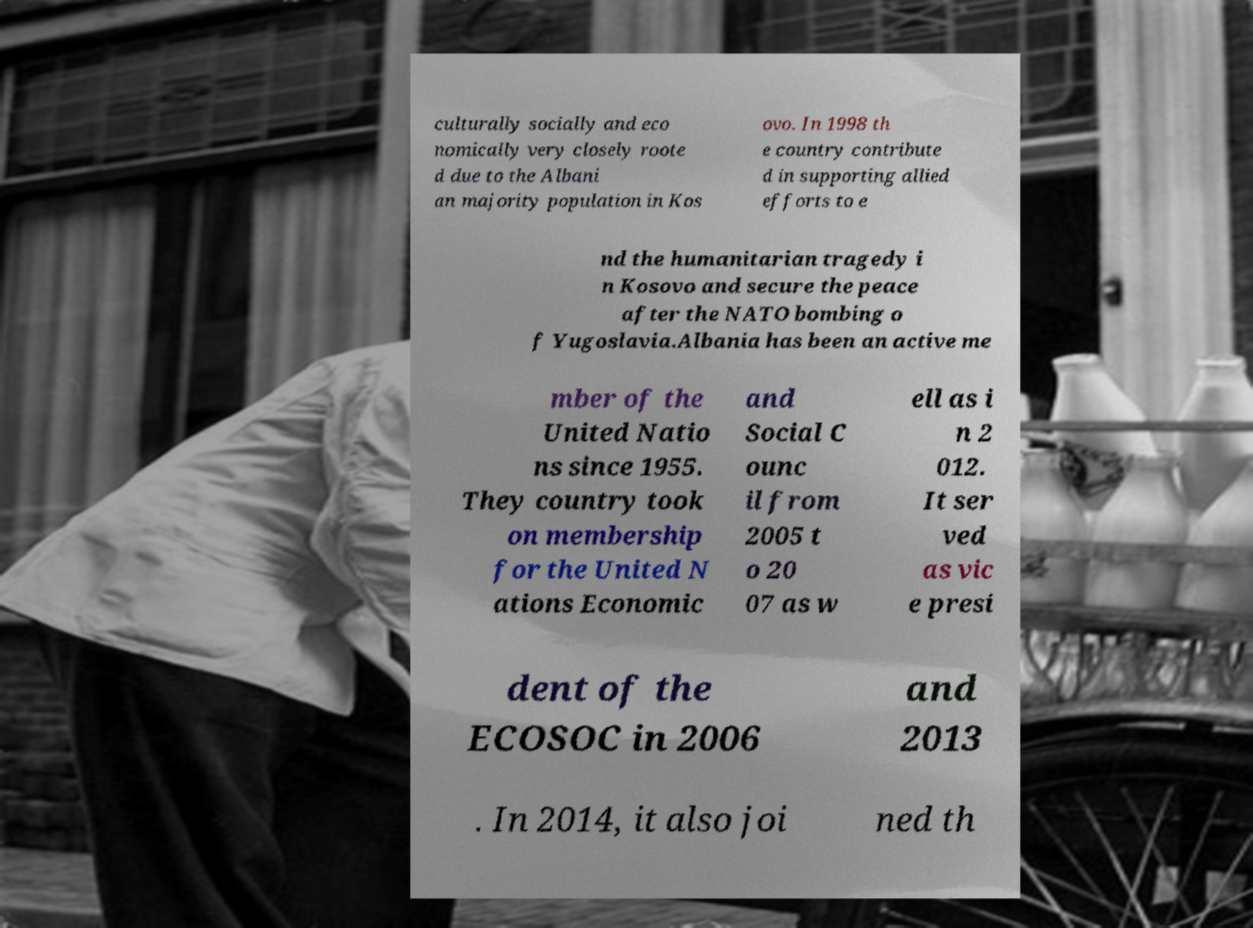Can you accurately transcribe the text from the provided image for me? culturally socially and eco nomically very closely roote d due to the Albani an majority population in Kos ovo. In 1998 th e country contribute d in supporting allied efforts to e nd the humanitarian tragedy i n Kosovo and secure the peace after the NATO bombing o f Yugoslavia.Albania has been an active me mber of the United Natio ns since 1955. They country took on membership for the United N ations Economic and Social C ounc il from 2005 t o 20 07 as w ell as i n 2 012. It ser ved as vic e presi dent of the ECOSOC in 2006 and 2013 . In 2014, it also joi ned th 